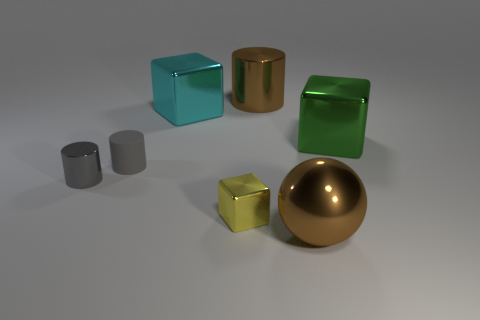Is the number of big brown objects in front of the green shiny thing greater than the number of big green metal cubes that are left of the small matte cylinder?
Offer a very short reply. Yes. Are the large cyan thing and the big green object made of the same material?
Offer a very short reply. Yes. The large metal thing that is both behind the rubber cylinder and in front of the large cyan shiny object has what shape?
Offer a terse response. Cube. There is a big green thing that is the same material as the large brown cylinder; what shape is it?
Give a very brief answer. Cube. Is there a tiny brown metallic cylinder?
Keep it short and to the point. No. Are there any brown metallic objects that are right of the big brown thing that is behind the small yellow block?
Your response must be concise. Yes. There is another large object that is the same shape as the cyan object; what material is it?
Make the answer very short. Metal. Is the number of large brown spheres greater than the number of gray cylinders?
Provide a succinct answer. No. There is a ball; is it the same color as the metal cylinder right of the tiny gray metal thing?
Give a very brief answer. Yes. What is the color of the metallic object that is left of the small yellow shiny object and behind the small gray metal thing?
Your answer should be very brief. Cyan. 